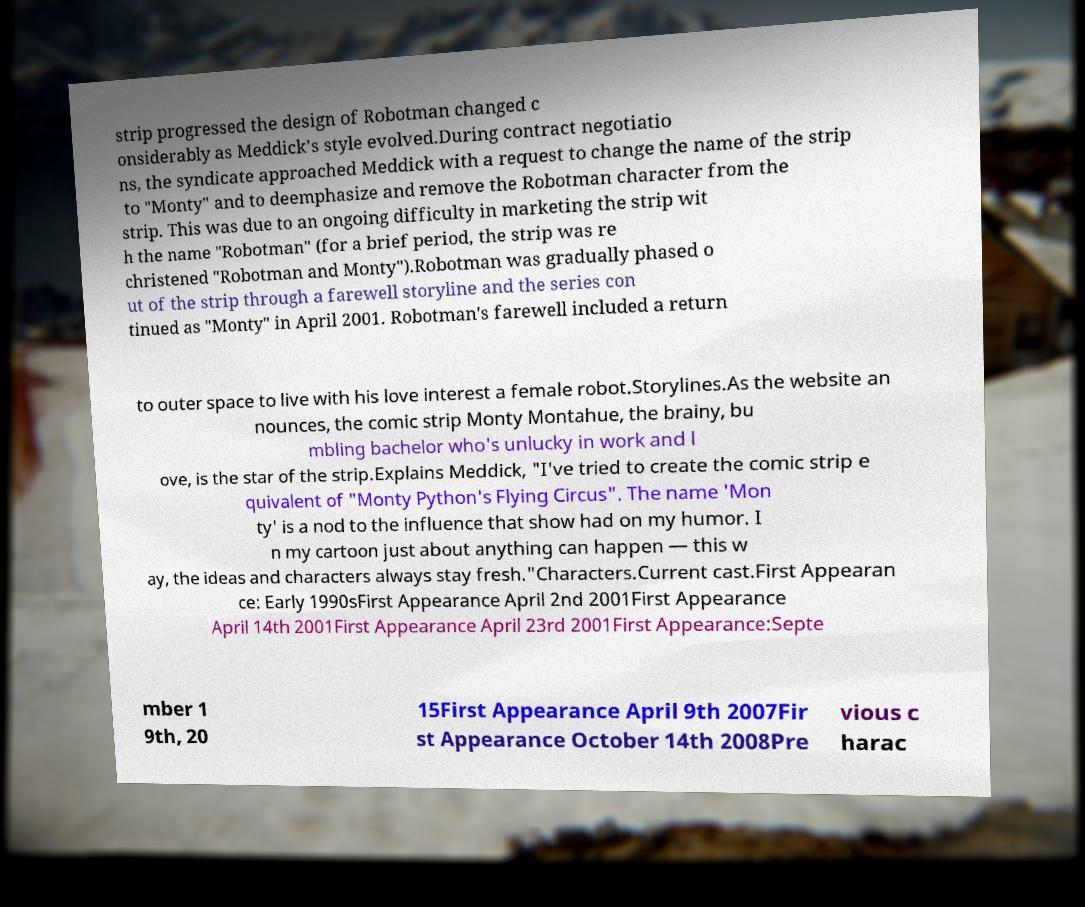For documentation purposes, I need the text within this image transcribed. Could you provide that? strip progressed the design of Robotman changed c onsiderably as Meddick's style evolved.During contract negotiatio ns, the syndicate approached Meddick with a request to change the name of the strip to "Monty" and to deemphasize and remove the Robotman character from the strip. This was due to an ongoing difficulty in marketing the strip wit h the name "Robotman" (for a brief period, the strip was re christened "Robotman and Monty").Robotman was gradually phased o ut of the strip through a farewell storyline and the series con tinued as "Monty" in April 2001. Robotman's farewell included a return to outer space to live with his love interest a female robot.Storylines.As the website an nounces, the comic strip Monty Montahue, the brainy, bu mbling bachelor who's unlucky in work and l ove, is the star of the strip.Explains Meddick, "I've tried to create the comic strip e quivalent of "Monty Python's Flying Circus". The name 'Mon ty' is a nod to the influence that show had on my humor. I n my cartoon just about anything can happen — this w ay, the ideas and characters always stay fresh."Characters.Current cast.First Appearan ce: Early 1990sFirst Appearance April 2nd 2001First Appearance April 14th 2001First Appearance April 23rd 2001First Appearance:Septe mber 1 9th, 20 15First Appearance April 9th 2007Fir st Appearance October 14th 2008Pre vious c harac 